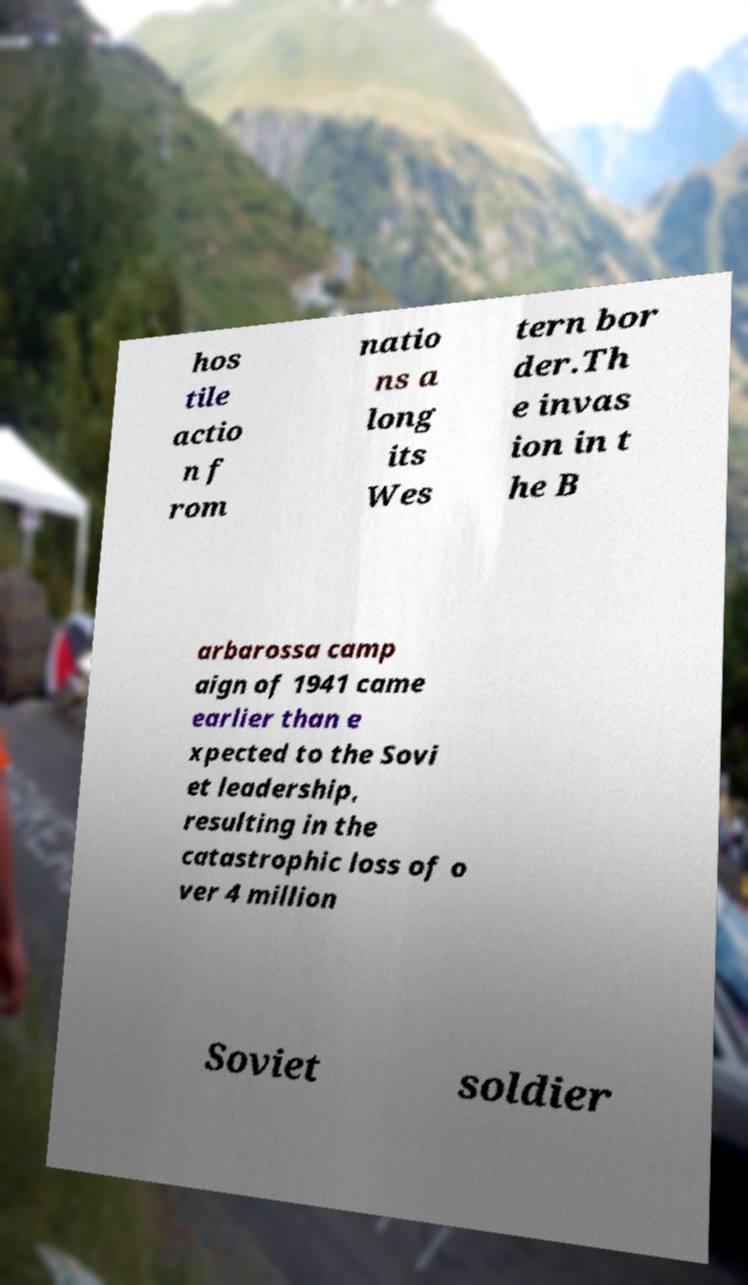I need the written content from this picture converted into text. Can you do that? hos tile actio n f rom natio ns a long its Wes tern bor der.Th e invas ion in t he B arbarossa camp aign of 1941 came earlier than e xpected to the Sovi et leadership, resulting in the catastrophic loss of o ver 4 million Soviet soldier 